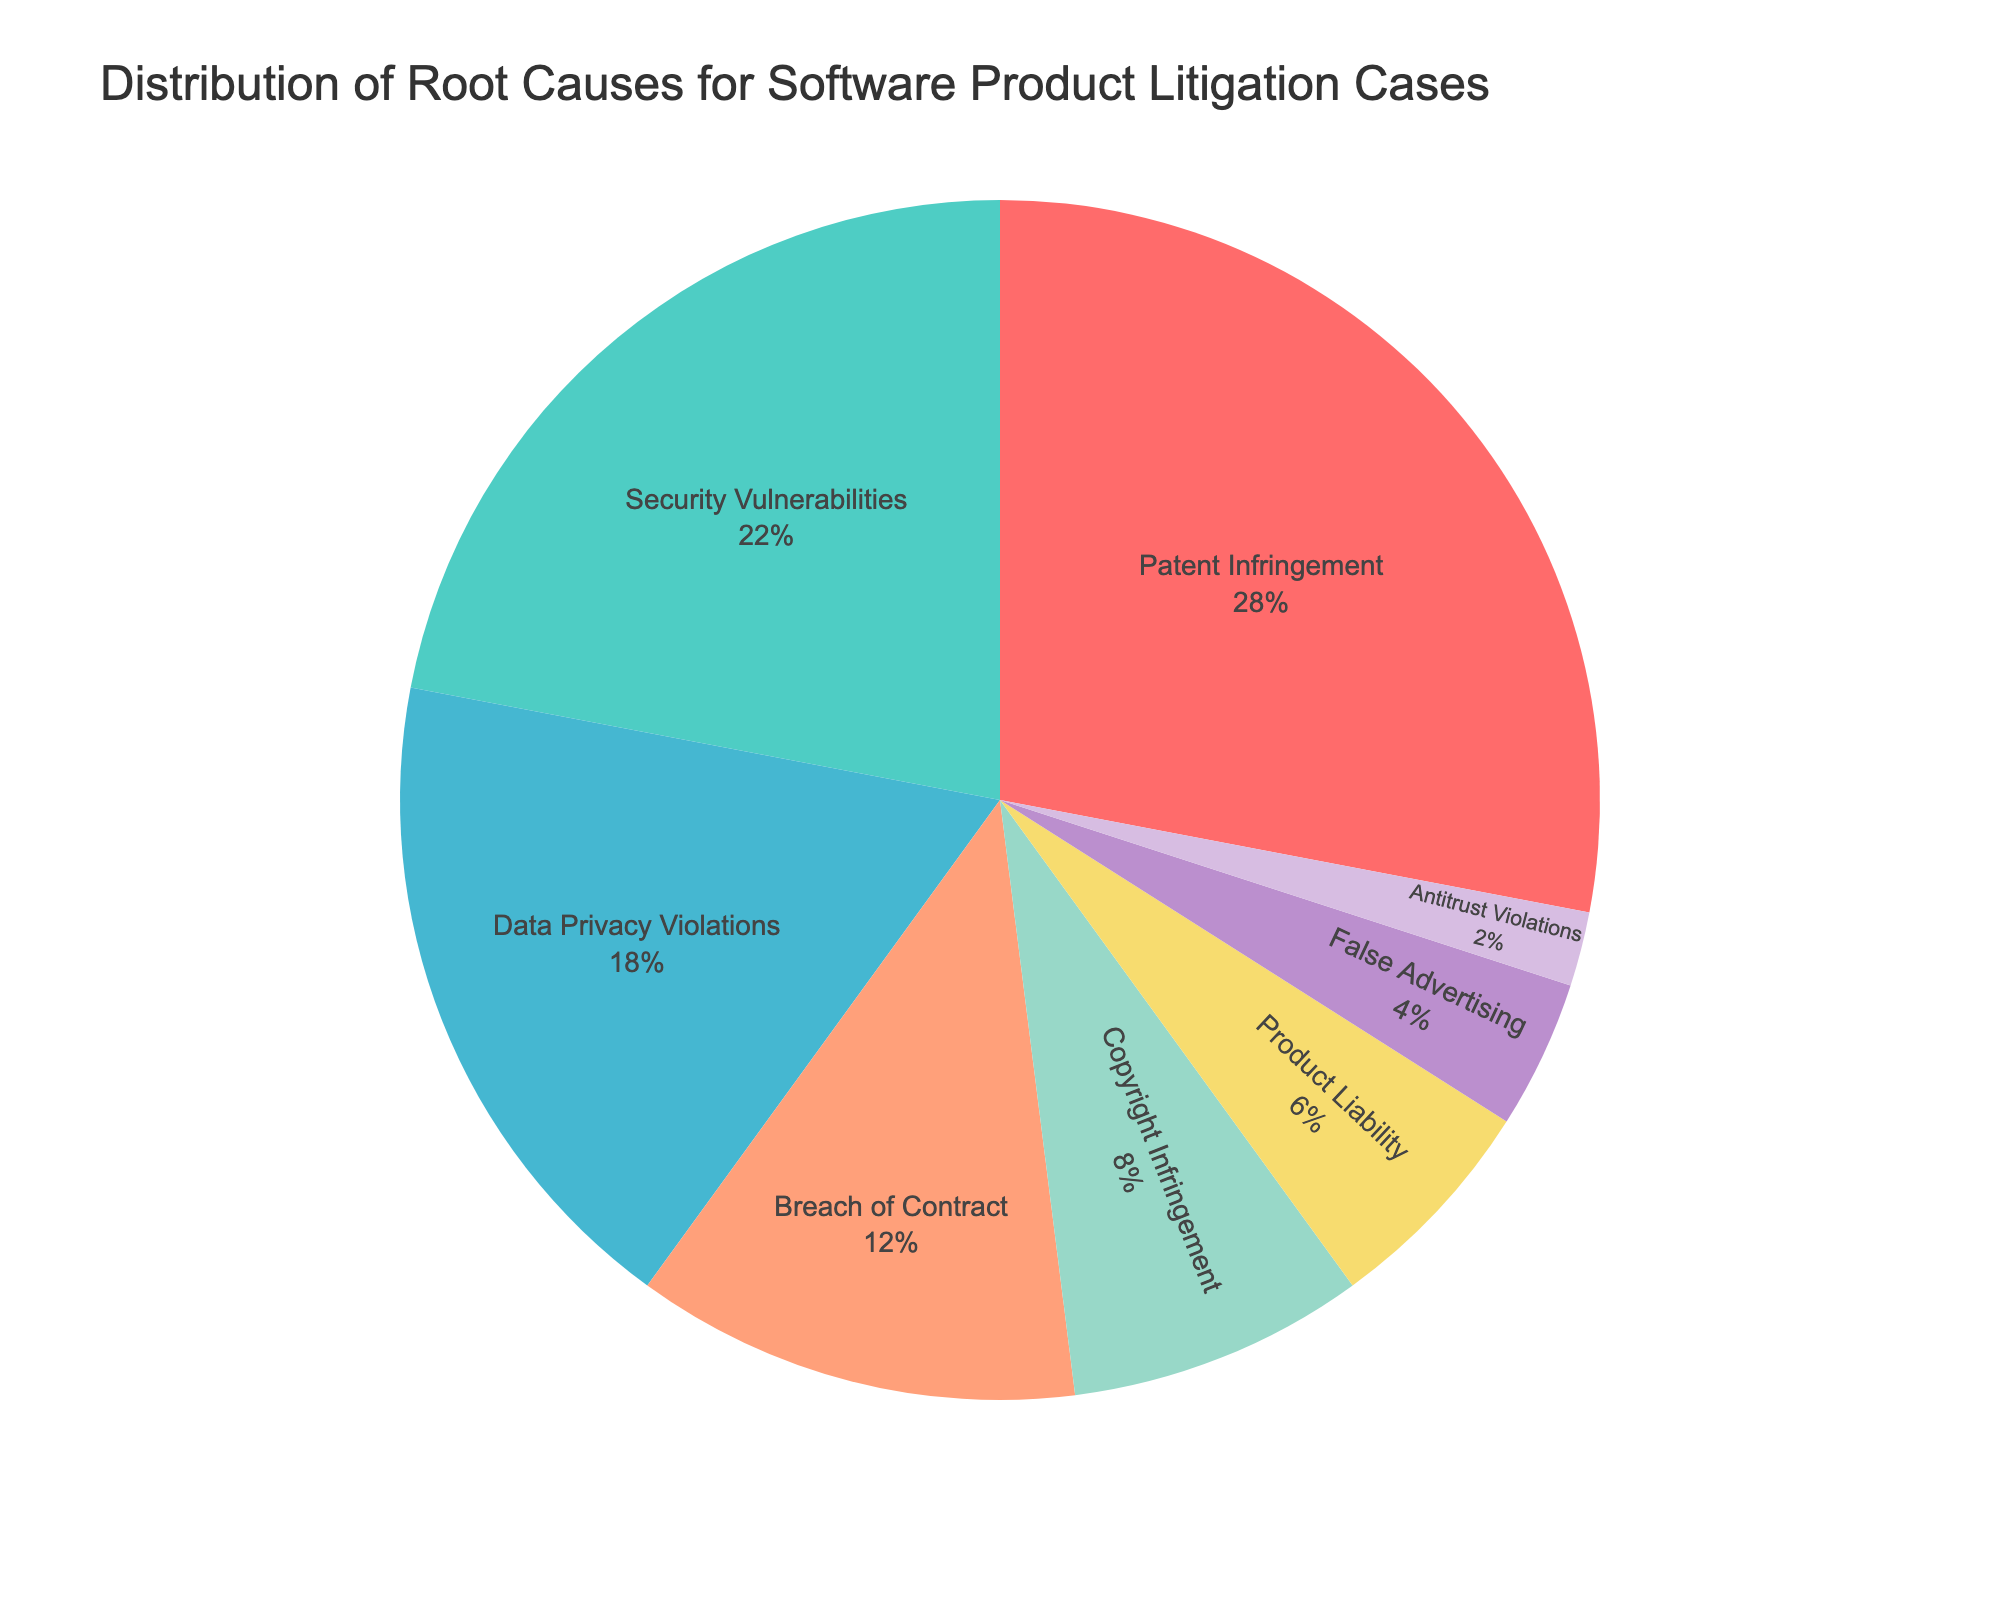Which root cause has the highest percentage of software product litigation cases? The largest slice of the pie chart represents the root cause with the highest percentage. 28% is the largest slice attributed to Patent Infringement.
Answer: Patent Infringement What is the combined percentage of Data Privacy Violations and Security Vulnerabilities? To find the combined percentage, add the percentages for Data Privacy Violations and Security Vulnerabilities. They're 18% and 22% respectively, so the sum is 18% + 22% = 40%.
Answer: 40% Which causes have less than 10% each of the litigation cases? The segments smaller than 10% on the pie chart are Copyright Infringement, Product Liability, False Advertising, and Antitrust Violations. They show 8%, 6%, 4%, and 2% respectively.
Answer: Copyright Infringement, Product Liability, False Advertising, Antitrust Violations How much higher is the percentage of Patent Infringement compared to Breach of Contract? Subtract the percentage of Breach of Contract from the percentage of Patent Infringement: 28% - 12% = 16%.
Answer: 16% What percentage of the litigation cases are related to intellectual property issues (Patent Infringement and Copyright Infringement)? Add the percentages for Patent Infringement and Copyright Infringement. They're 28% and 8% respectively, so the sum is 28% + 8% = 36%.
Answer: 36% Is the percentage of Security Vulnerabilities greater than the sum of Product Liability and False Advertising? Compare the percentage of Security Vulnerabilities (22%) with the combined percentage of Product Liability (6%) and False Advertising (4%). The sum is 6% + 4% = 10%, which is less than 22%.
Answer: Yes What is the average percentage for Breach of Contract, Data Privacy Violations, and Product Liability? Add the percentages for Breach of Contract (12%), Data Privacy Violations (18%), and Product Liability (6%). The sum is 12% + 18% + 6% = 36%. Divide by the number of categories (3) to get the average: 36% / 3 = 12%.
Answer: 12% Which root causes are depicted in shades of blue/green? Security Vulnerabilities (greenish), Data Privacy Violations (bluish), and Patent Infringement (reddish which is close to pink). By color logic, Security Vulnerabilities and Data Privacy Violations fit the description best.
Answer: Security Vulnerabilities, Data Privacy Violations What is the smallest category and its percentage in the pie chart? Identify the smallest slice in the pie chart. The smallest slice is Antitrust Violations. The percentage indicated for Antitrust Violations is 2%.
Answer: Antitrust Violations, 2% Does Breach of Contract have a larger percentage than Product Liability? Compare the percentage of Breach of Contract (12%) with Product Liability (6%). 12% is greater than 6%.
Answer: Yes 